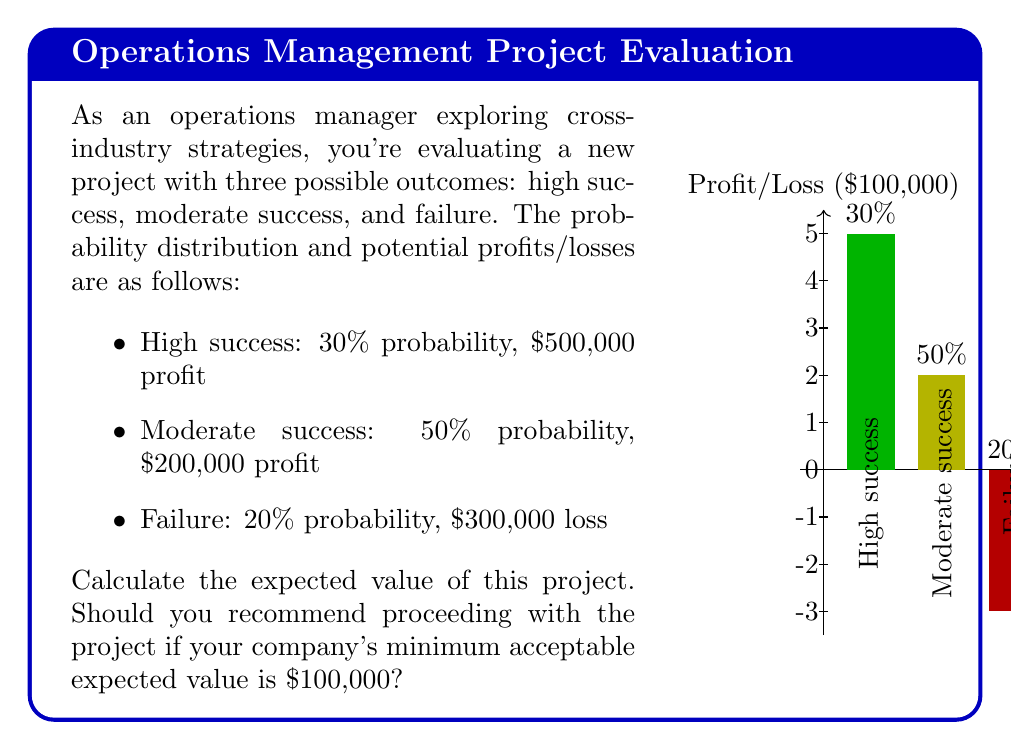Can you solve this math problem? To solve this problem, we'll use the concept of expected value, which is calculated by multiplying each possible outcome by its probability and then summing these products.

Let's break it down step-by-step:

1) First, let's calculate the expected value for each outcome:

   High success: $E_1 = 0.30 \times \$500,000 = \$150,000$
   Moderate success: $E_2 = 0.50 \times \$200,000 = \$100,000$
   Failure: $E_3 = 0.20 \times (-\$300,000) = -\$60,000$

2) Now, we sum these expected values to get the total expected value of the project:

   $$E_{total} = E_1 + E_2 + E_3 = \$150,000 + \$100,000 + (-\$60,000) = \$190,000$$

3) To determine if we should recommend proceeding with the project, we compare the calculated expected value to the company's minimum acceptable expected value:

   $\$190,000 > \$100,000$

Since the expected value of the project ($190,000) is greater than the company's minimum acceptable expected value ($100,000), we should recommend proceeding with the project.

This method of evaluating project risks using probability distributions and expected value calculations allows managers to make informed decisions based on quantitative analysis, even when faced with uncertainty.
Answer: $190,000; Yes, proceed with the project. 